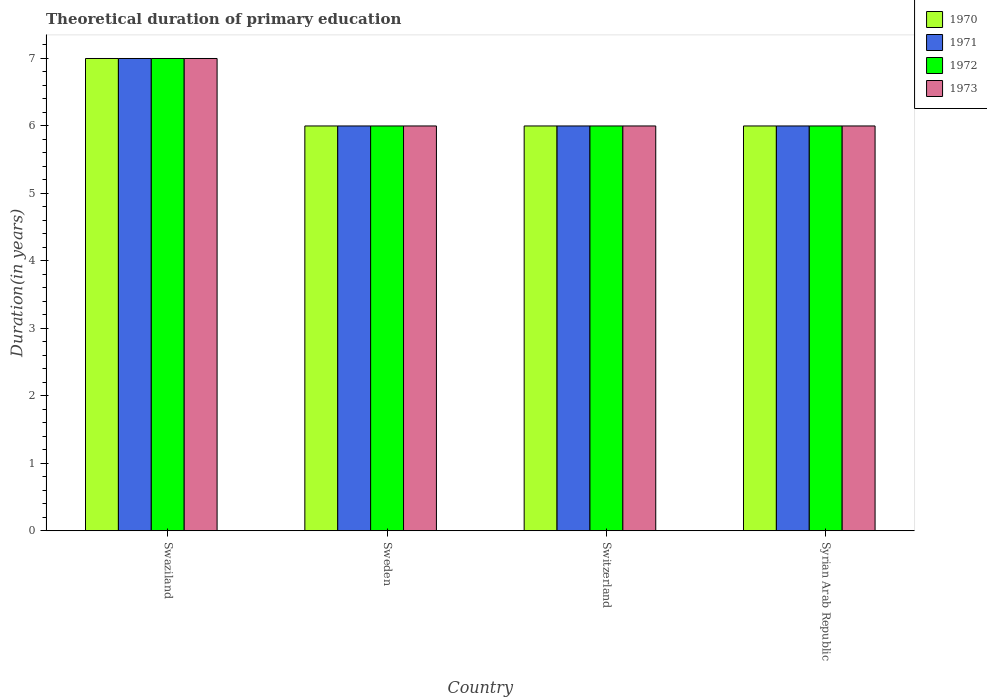How many different coloured bars are there?
Offer a very short reply. 4. Are the number of bars on each tick of the X-axis equal?
Offer a terse response. Yes. What is the label of the 4th group of bars from the left?
Your response must be concise. Syrian Arab Republic. What is the total theoretical duration of primary education in 1973 in Swaziland?
Make the answer very short. 7. Across all countries, what is the maximum total theoretical duration of primary education in 1970?
Your answer should be very brief. 7. In which country was the total theoretical duration of primary education in 1973 maximum?
Make the answer very short. Swaziland. In which country was the total theoretical duration of primary education in 1970 minimum?
Your answer should be compact. Sweden. What is the total total theoretical duration of primary education in 1970 in the graph?
Give a very brief answer. 25. What is the difference between the total theoretical duration of primary education in 1973 in Swaziland and that in Switzerland?
Offer a very short reply. 1. What is the difference between the total theoretical duration of primary education in 1971 in Sweden and the total theoretical duration of primary education in 1972 in Swaziland?
Ensure brevity in your answer.  -1. What is the average total theoretical duration of primary education in 1971 per country?
Offer a terse response. 6.25. What is the difference between the total theoretical duration of primary education of/in 1971 and total theoretical duration of primary education of/in 1973 in Syrian Arab Republic?
Keep it short and to the point. 0. What is the ratio of the total theoretical duration of primary education in 1972 in Swaziland to that in Syrian Arab Republic?
Keep it short and to the point. 1.17. Is the total theoretical duration of primary education in 1971 in Sweden less than that in Switzerland?
Provide a succinct answer. No. In how many countries, is the total theoretical duration of primary education in 1972 greater than the average total theoretical duration of primary education in 1972 taken over all countries?
Keep it short and to the point. 1. Is it the case that in every country, the sum of the total theoretical duration of primary education in 1972 and total theoretical duration of primary education in 1970 is greater than the sum of total theoretical duration of primary education in 1971 and total theoretical duration of primary education in 1973?
Your response must be concise. No. What does the 1st bar from the left in Syrian Arab Republic represents?
Your answer should be very brief. 1970. What does the 3rd bar from the right in Switzerland represents?
Provide a short and direct response. 1971. Is it the case that in every country, the sum of the total theoretical duration of primary education in 1970 and total theoretical duration of primary education in 1971 is greater than the total theoretical duration of primary education in 1972?
Give a very brief answer. Yes. How many bars are there?
Provide a succinct answer. 16. Are all the bars in the graph horizontal?
Your answer should be compact. No. What is the difference between two consecutive major ticks on the Y-axis?
Keep it short and to the point. 1. Are the values on the major ticks of Y-axis written in scientific E-notation?
Keep it short and to the point. No. Does the graph contain any zero values?
Provide a succinct answer. No. Where does the legend appear in the graph?
Ensure brevity in your answer.  Top right. How many legend labels are there?
Your response must be concise. 4. What is the title of the graph?
Make the answer very short. Theoretical duration of primary education. What is the label or title of the X-axis?
Offer a terse response. Country. What is the label or title of the Y-axis?
Provide a short and direct response. Duration(in years). What is the Duration(in years) in 1971 in Swaziland?
Provide a succinct answer. 7. What is the Duration(in years) in 1972 in Swaziland?
Offer a very short reply. 7. What is the Duration(in years) of 1970 in Sweden?
Your answer should be very brief. 6. What is the Duration(in years) of 1972 in Sweden?
Ensure brevity in your answer.  6. What is the Duration(in years) of 1970 in Switzerland?
Give a very brief answer. 6. What is the Duration(in years) in 1971 in Switzerland?
Offer a very short reply. 6. What is the Duration(in years) of 1973 in Switzerland?
Keep it short and to the point. 6. Across all countries, what is the maximum Duration(in years) of 1970?
Give a very brief answer. 7. Across all countries, what is the maximum Duration(in years) of 1971?
Your response must be concise. 7. Across all countries, what is the maximum Duration(in years) in 1972?
Provide a short and direct response. 7. Across all countries, what is the maximum Duration(in years) in 1973?
Make the answer very short. 7. Across all countries, what is the minimum Duration(in years) of 1970?
Provide a short and direct response. 6. Across all countries, what is the minimum Duration(in years) in 1972?
Ensure brevity in your answer.  6. What is the total Duration(in years) in 1973 in the graph?
Your answer should be very brief. 25. What is the difference between the Duration(in years) of 1970 in Swaziland and that in Sweden?
Make the answer very short. 1. What is the difference between the Duration(in years) of 1971 in Swaziland and that in Sweden?
Give a very brief answer. 1. What is the difference between the Duration(in years) in 1972 in Swaziland and that in Sweden?
Make the answer very short. 1. What is the difference between the Duration(in years) in 1970 in Swaziland and that in Syrian Arab Republic?
Your answer should be very brief. 1. What is the difference between the Duration(in years) in 1972 in Swaziland and that in Syrian Arab Republic?
Offer a very short reply. 1. What is the difference between the Duration(in years) of 1973 in Swaziland and that in Syrian Arab Republic?
Make the answer very short. 1. What is the difference between the Duration(in years) in 1971 in Sweden and that in Switzerland?
Give a very brief answer. 0. What is the difference between the Duration(in years) in 1972 in Sweden and that in Switzerland?
Your answer should be very brief. 0. What is the difference between the Duration(in years) of 1973 in Sweden and that in Switzerland?
Keep it short and to the point. 0. What is the difference between the Duration(in years) in 1971 in Sweden and that in Syrian Arab Republic?
Your answer should be compact. 0. What is the difference between the Duration(in years) in 1972 in Sweden and that in Syrian Arab Republic?
Your response must be concise. 0. What is the difference between the Duration(in years) in 1973 in Sweden and that in Syrian Arab Republic?
Your response must be concise. 0. What is the difference between the Duration(in years) of 1972 in Switzerland and that in Syrian Arab Republic?
Provide a short and direct response. 0. What is the difference between the Duration(in years) of 1970 in Swaziland and the Duration(in years) of 1971 in Sweden?
Your answer should be compact. 1. What is the difference between the Duration(in years) in 1971 in Swaziland and the Duration(in years) in 1972 in Switzerland?
Provide a succinct answer. 1. What is the difference between the Duration(in years) of 1971 in Swaziland and the Duration(in years) of 1973 in Switzerland?
Offer a terse response. 1. What is the difference between the Duration(in years) in 1970 in Swaziland and the Duration(in years) in 1973 in Syrian Arab Republic?
Your response must be concise. 1. What is the difference between the Duration(in years) of 1970 in Sweden and the Duration(in years) of 1972 in Switzerland?
Offer a terse response. 0. What is the difference between the Duration(in years) of 1971 in Sweden and the Duration(in years) of 1972 in Switzerland?
Your answer should be very brief. 0. What is the difference between the Duration(in years) of 1972 in Sweden and the Duration(in years) of 1973 in Switzerland?
Your answer should be compact. 0. What is the difference between the Duration(in years) in 1970 in Sweden and the Duration(in years) in 1973 in Syrian Arab Republic?
Give a very brief answer. 0. What is the difference between the Duration(in years) of 1971 in Sweden and the Duration(in years) of 1972 in Syrian Arab Republic?
Offer a very short reply. 0. What is the difference between the Duration(in years) of 1970 in Switzerland and the Duration(in years) of 1972 in Syrian Arab Republic?
Keep it short and to the point. 0. What is the average Duration(in years) of 1970 per country?
Offer a terse response. 6.25. What is the average Duration(in years) in 1971 per country?
Your answer should be compact. 6.25. What is the average Duration(in years) in 1972 per country?
Give a very brief answer. 6.25. What is the average Duration(in years) of 1973 per country?
Your answer should be compact. 6.25. What is the difference between the Duration(in years) in 1970 and Duration(in years) in 1971 in Swaziland?
Your answer should be very brief. 0. What is the difference between the Duration(in years) in 1970 and Duration(in years) in 1973 in Swaziland?
Your response must be concise. 0. What is the difference between the Duration(in years) in 1972 and Duration(in years) in 1973 in Swaziland?
Provide a short and direct response. 0. What is the difference between the Duration(in years) in 1970 and Duration(in years) in 1971 in Sweden?
Your answer should be very brief. 0. What is the difference between the Duration(in years) of 1970 and Duration(in years) of 1972 in Sweden?
Make the answer very short. 0. What is the difference between the Duration(in years) of 1971 and Duration(in years) of 1972 in Sweden?
Ensure brevity in your answer.  0. What is the difference between the Duration(in years) of 1970 and Duration(in years) of 1971 in Switzerland?
Make the answer very short. 0. What is the difference between the Duration(in years) of 1971 and Duration(in years) of 1972 in Switzerland?
Offer a terse response. 0. What is the difference between the Duration(in years) in 1972 and Duration(in years) in 1973 in Syrian Arab Republic?
Offer a terse response. 0. What is the ratio of the Duration(in years) of 1970 in Swaziland to that in Sweden?
Make the answer very short. 1.17. What is the ratio of the Duration(in years) in 1972 in Swaziland to that in Sweden?
Offer a terse response. 1.17. What is the ratio of the Duration(in years) in 1972 in Swaziland to that in Switzerland?
Offer a very short reply. 1.17. What is the ratio of the Duration(in years) in 1970 in Swaziland to that in Syrian Arab Republic?
Offer a terse response. 1.17. What is the ratio of the Duration(in years) of 1971 in Swaziland to that in Syrian Arab Republic?
Offer a very short reply. 1.17. What is the ratio of the Duration(in years) in 1970 in Sweden to that in Switzerland?
Provide a short and direct response. 1. What is the ratio of the Duration(in years) of 1973 in Sweden to that in Switzerland?
Your answer should be compact. 1. What is the ratio of the Duration(in years) of 1971 in Sweden to that in Syrian Arab Republic?
Give a very brief answer. 1. What is the ratio of the Duration(in years) of 1973 in Sweden to that in Syrian Arab Republic?
Your answer should be very brief. 1. What is the ratio of the Duration(in years) in 1972 in Switzerland to that in Syrian Arab Republic?
Your response must be concise. 1. What is the ratio of the Duration(in years) in 1973 in Switzerland to that in Syrian Arab Republic?
Your answer should be very brief. 1. What is the difference between the highest and the second highest Duration(in years) in 1970?
Your answer should be very brief. 1. What is the difference between the highest and the second highest Duration(in years) of 1971?
Make the answer very short. 1. What is the difference between the highest and the lowest Duration(in years) of 1970?
Your answer should be very brief. 1. What is the difference between the highest and the lowest Duration(in years) of 1972?
Make the answer very short. 1. What is the difference between the highest and the lowest Duration(in years) in 1973?
Provide a succinct answer. 1. 